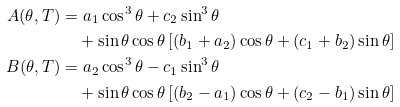<formula> <loc_0><loc_0><loc_500><loc_500>A ( \theta , T ) = & \ a _ { 1 } \cos ^ { 3 } \theta + c _ { 2 } \sin ^ { 3 } \theta \\ & + \sin \theta \cos \theta \left [ ( b _ { 1 } + a _ { 2 } ) \cos \theta + ( c _ { 1 } + b _ { 2 } ) \sin \theta \right ] \\ B ( \theta , T ) = & \ a _ { 2 } \cos ^ { 3 } \theta - c _ { 1 } \sin ^ { 3 } \theta \\ & + \sin \theta \cos \theta \left [ ( b _ { 2 } - a _ { 1 } ) \cos \theta + ( c _ { 2 } - b _ { 1 } ) \sin \theta \right ]</formula> 